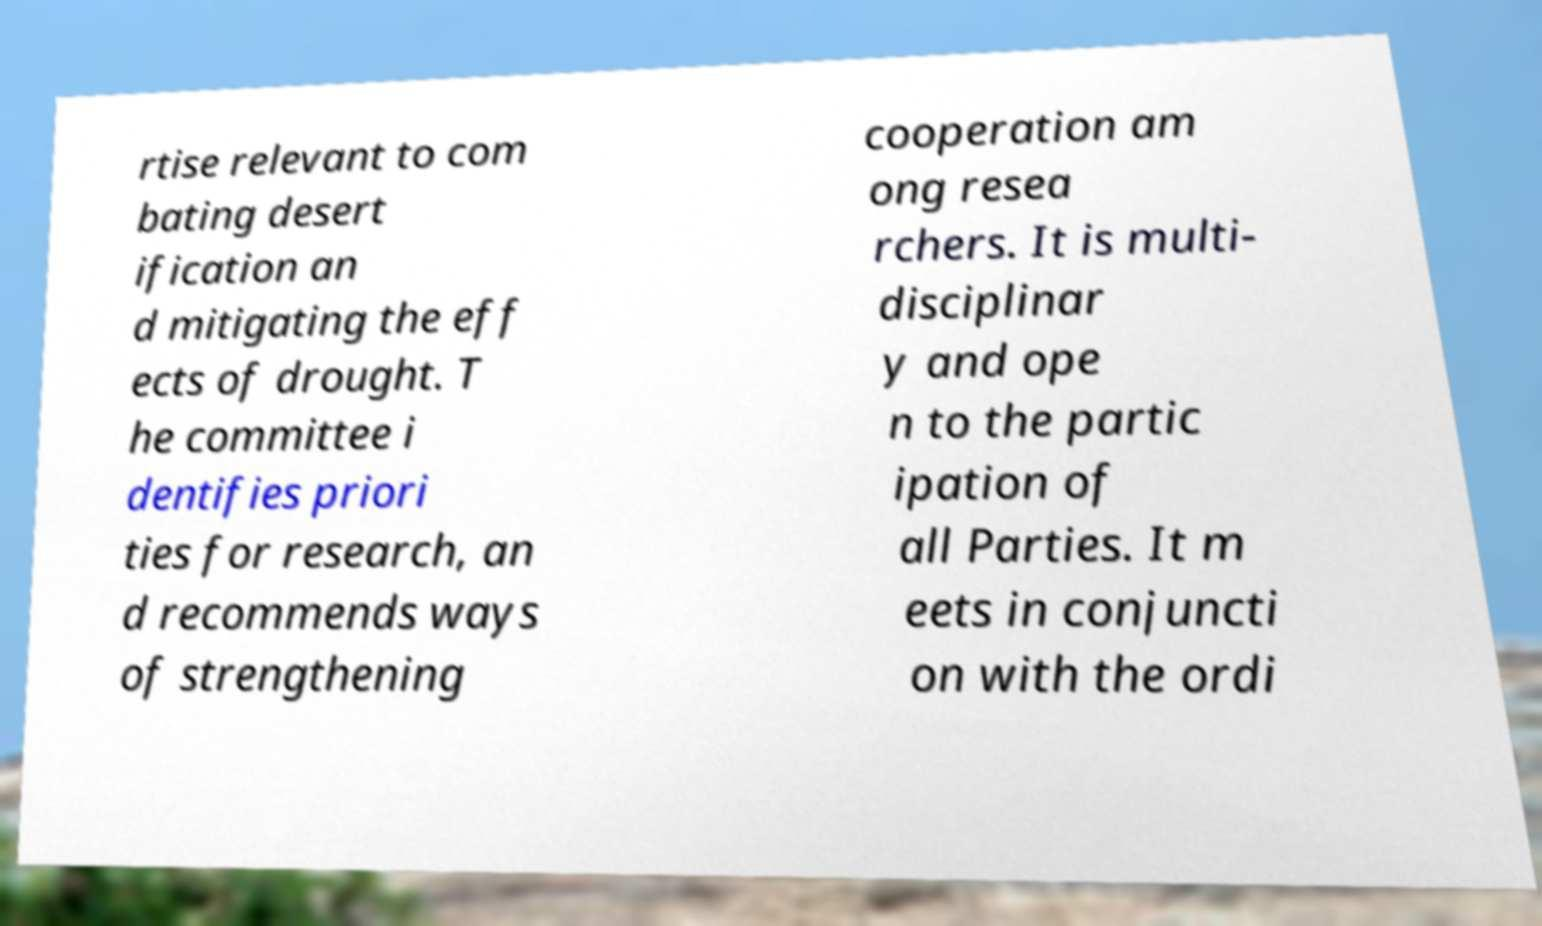There's text embedded in this image that I need extracted. Can you transcribe it verbatim? rtise relevant to com bating desert ification an d mitigating the eff ects of drought. T he committee i dentifies priori ties for research, an d recommends ways of strengthening cooperation am ong resea rchers. It is multi- disciplinar y and ope n to the partic ipation of all Parties. It m eets in conjuncti on with the ordi 